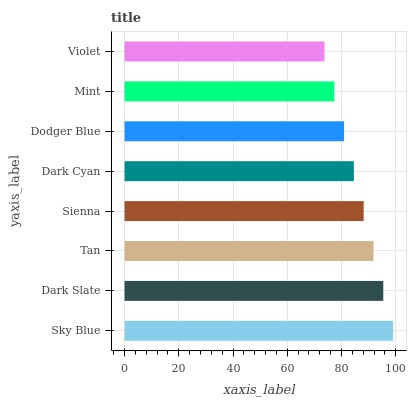Is Violet the minimum?
Answer yes or no. Yes. Is Sky Blue the maximum?
Answer yes or no. Yes. Is Dark Slate the minimum?
Answer yes or no. No. Is Dark Slate the maximum?
Answer yes or no. No. Is Sky Blue greater than Dark Slate?
Answer yes or no. Yes. Is Dark Slate less than Sky Blue?
Answer yes or no. Yes. Is Dark Slate greater than Sky Blue?
Answer yes or no. No. Is Sky Blue less than Dark Slate?
Answer yes or no. No. Is Sienna the high median?
Answer yes or no. Yes. Is Dark Cyan the low median?
Answer yes or no. Yes. Is Tan the high median?
Answer yes or no. No. Is Dodger Blue the low median?
Answer yes or no. No. 